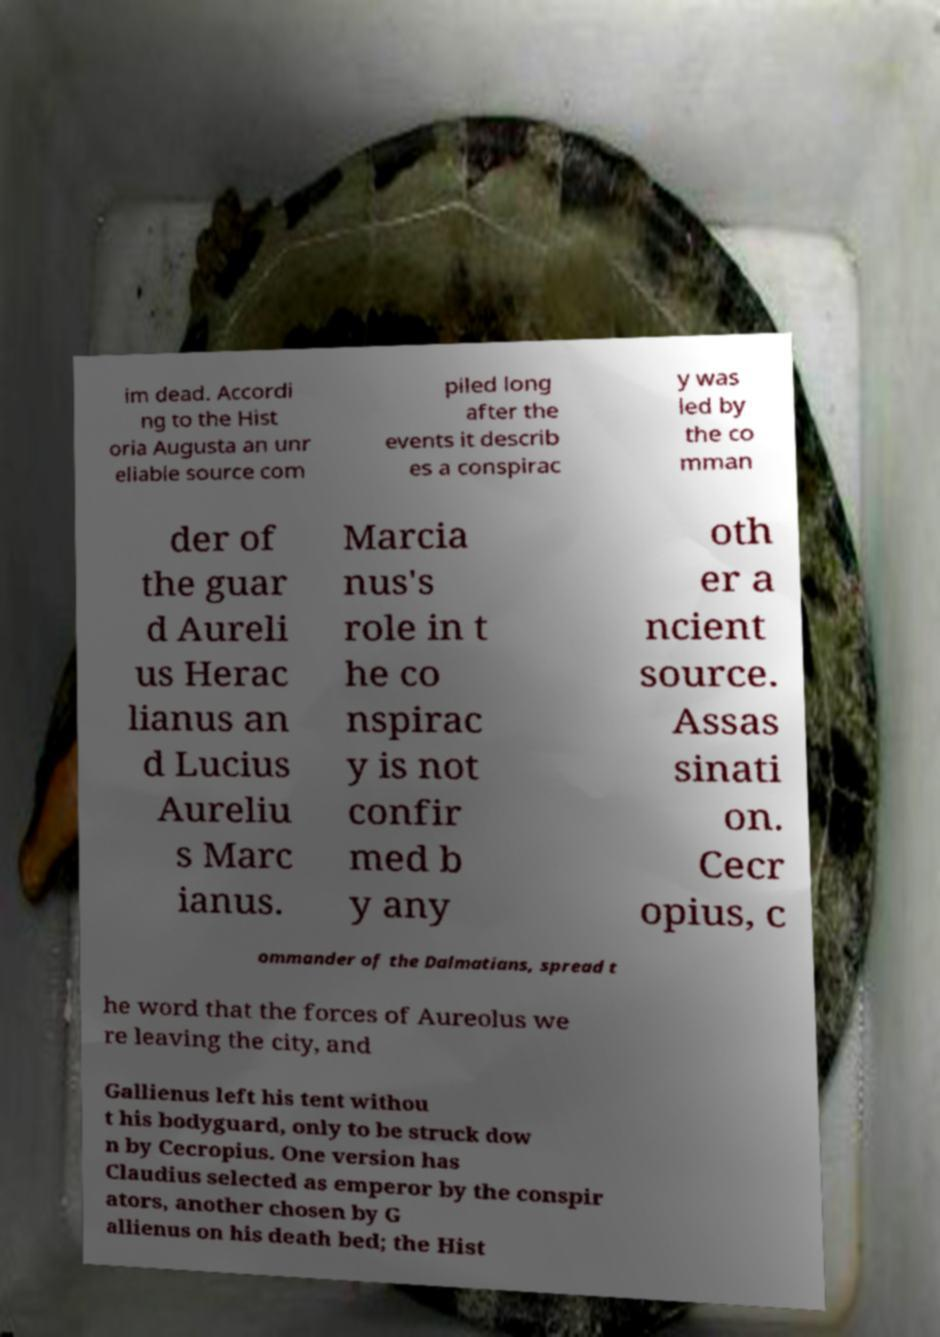Can you read and provide the text displayed in the image?This photo seems to have some interesting text. Can you extract and type it out for me? im dead. Accordi ng to the Hist oria Augusta an unr eliable source com piled long after the events it describ es a conspirac y was led by the co mman der of the guar d Aureli us Herac lianus an d Lucius Aureliu s Marc ianus. Marcia nus's role in t he co nspirac y is not confir med b y any oth er a ncient source. Assas sinati on. Cecr opius, c ommander of the Dalmatians, spread t he word that the forces of Aureolus we re leaving the city, and Gallienus left his tent withou t his bodyguard, only to be struck dow n by Cecropius. One version has Claudius selected as emperor by the conspir ators, another chosen by G allienus on his death bed; the Hist 